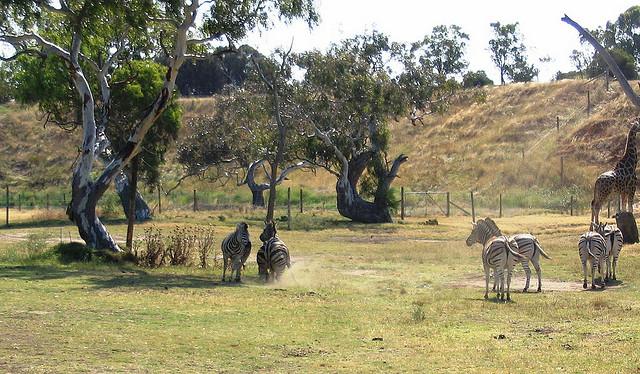Are all these animals part of the same herd?
Short answer required. Yes. What is the animal that is different?
Keep it brief. Giraffe. How many animals in the shot?
Concise answer only. 7. 